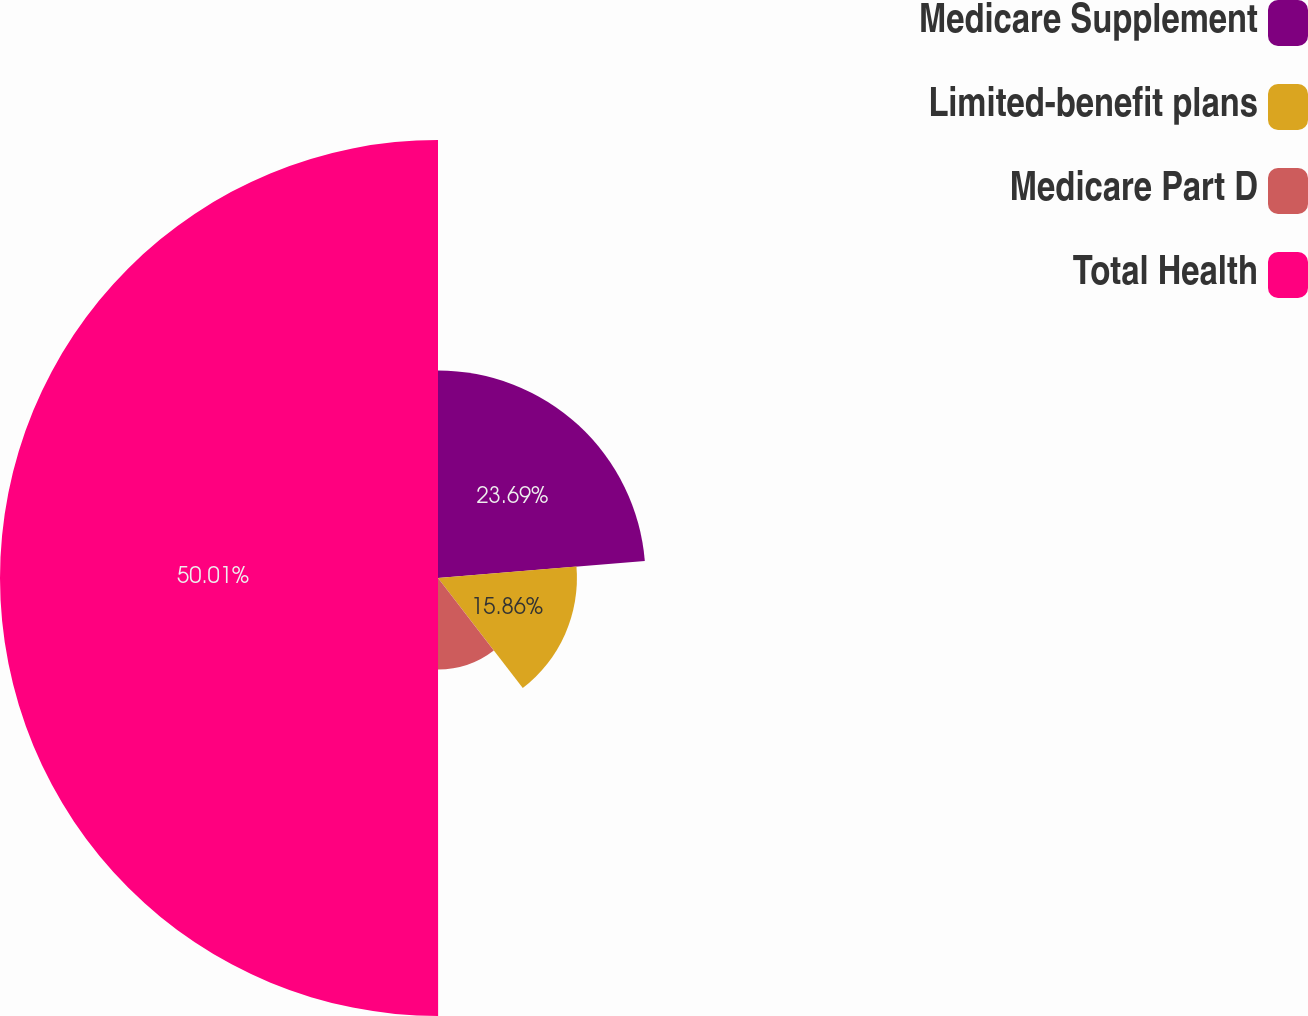<chart> <loc_0><loc_0><loc_500><loc_500><pie_chart><fcel>Medicare Supplement<fcel>Limited-benefit plans<fcel>Medicare Part D<fcel>Total Health<nl><fcel>23.69%<fcel>15.86%<fcel>10.44%<fcel>50.0%<nl></chart> 